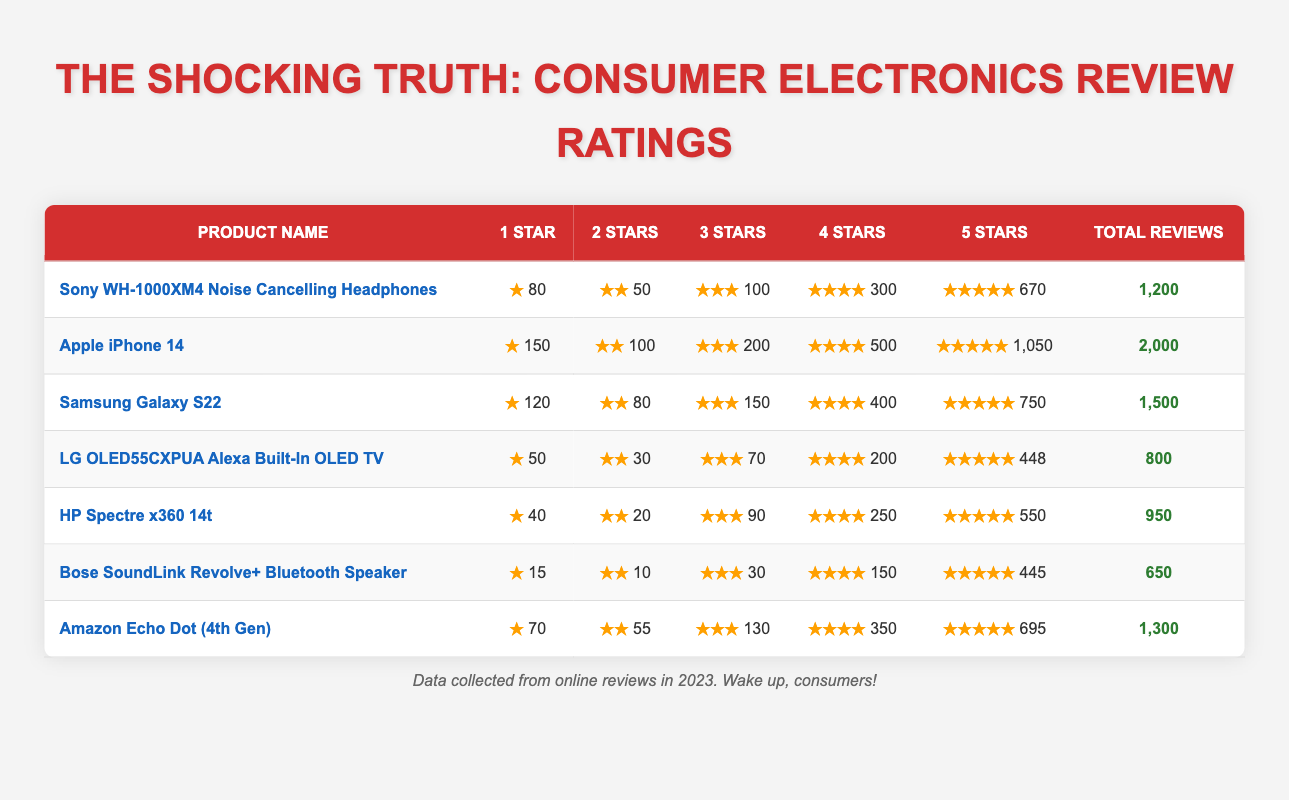What is the total number of reviews for the LG OLED55CXPUA Alexa Built-In OLED TV? The table shows that the total reviews for the LG OLED55CXPUA Alexa Built-In OLED TV is listed in the last column. Referring to that row, it shows a total of 800 reviews.
Answer: 800 Which product has the highest number of 1-star ratings? By examining the first column for 1-star ratings across all products, the Apple iPhone 14 has the highest number with 150, compared to other products.
Answer: Apple iPhone 14 What is the total number of 5-star ratings across all products? To find the total number of 5-star ratings, sum all the values from the '5 Stars' column: 670 + 1050 + 750 + 448 + 550 + 445 + 695 = 4138.
Answer: 4138 Is it true that the Sony WH-1000XM4 has more 4-star ratings than the Samsung Galaxy S22? Looking at the columns for 4-star ratings, Sony WH-1000XM4 has 300 while Samsung Galaxy S22 has 400. Therefore, the statement is false.
Answer: No What percentage of the total reviews for the Apple iPhone 14 are 5-star ratings? The total reviews for the Apple iPhone 14 is 2000, and the number of 5-star ratings is 1050. To calculate the percentage, divide 1050 by 2000 and multiply by 100: (1050 / 2000) * 100 = 52.5%.
Answer: 52.5% How many more total reviews does the Amazon Echo Dot (4th Gen) have compared to the Bose SoundLink Revolve+ Bluetooth Speaker? The Amazon Echo Dot (4th Gen) has 1300 reviews, while the Bose SoundLink Revolve+ Bluetooth Speaker has 650 reviews. The difference is 1300 - 650 = 650 reviews.
Answer: 650 Which product has the least number of total reviews? Checking the totals in the last column, the Bose SoundLink Revolve+ Bluetooth Speaker has the lowest number of total reviews at 650.
Answer: Bose SoundLink Revolve+ Bluetooth Speaker How many stars did the Samsung Galaxy S22 receive in total ratings? We calculate the total stars by multiplying the number of stars by the number of ratings for each category. For Samsung Galaxy S22: (120 * 1) + (80 * 2) + (150 * 3) + (400 * 4) + (750 * 5) = 120 + 160 + 450 + 1600 + 3750 = 6080 stars in total.
Answer: 6080 